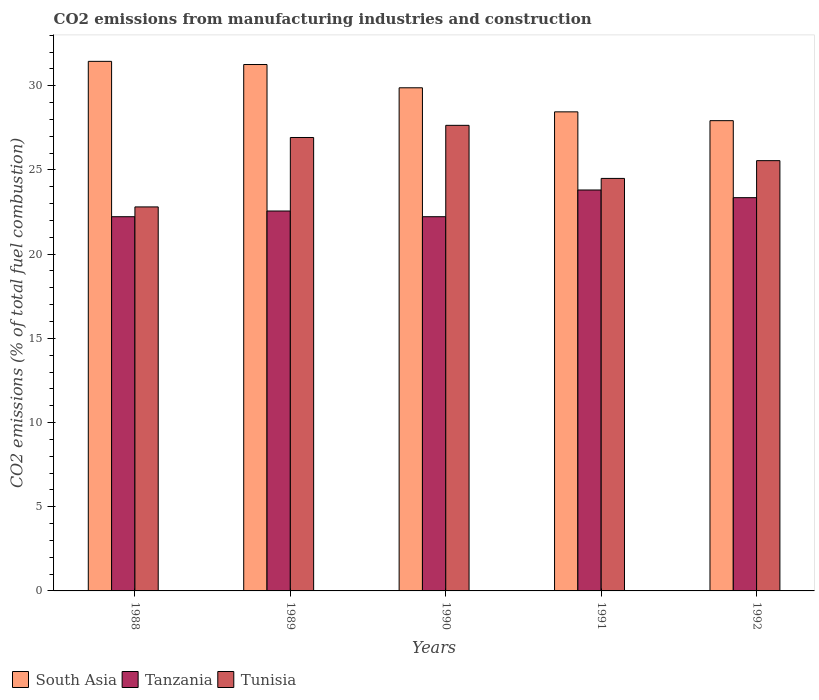How many groups of bars are there?
Your response must be concise. 5. Are the number of bars per tick equal to the number of legend labels?
Your response must be concise. Yes. Are the number of bars on each tick of the X-axis equal?
Offer a very short reply. Yes. In how many cases, is the number of bars for a given year not equal to the number of legend labels?
Provide a succinct answer. 0. What is the amount of CO2 emitted in Tunisia in 1989?
Provide a succinct answer. 26.93. Across all years, what is the maximum amount of CO2 emitted in Tunisia?
Offer a terse response. 27.65. Across all years, what is the minimum amount of CO2 emitted in South Asia?
Ensure brevity in your answer.  27.93. In which year was the amount of CO2 emitted in Tanzania minimum?
Offer a very short reply. 1988. What is the total amount of CO2 emitted in Tanzania in the graph?
Provide a succinct answer. 114.17. What is the difference between the amount of CO2 emitted in Tunisia in 1988 and that in 1992?
Your answer should be compact. -2.75. What is the difference between the amount of CO2 emitted in Tanzania in 1988 and the amount of CO2 emitted in South Asia in 1990?
Offer a terse response. -7.66. What is the average amount of CO2 emitted in South Asia per year?
Provide a succinct answer. 29.79. In the year 1992, what is the difference between the amount of CO2 emitted in South Asia and amount of CO2 emitted in Tunisia?
Keep it short and to the point. 2.37. What is the ratio of the amount of CO2 emitted in South Asia in 1991 to that in 1992?
Your answer should be compact. 1.02. Is the amount of CO2 emitted in Tunisia in 1988 less than that in 1989?
Provide a succinct answer. Yes. What is the difference between the highest and the second highest amount of CO2 emitted in Tunisia?
Give a very brief answer. 0.72. What is the difference between the highest and the lowest amount of CO2 emitted in South Asia?
Ensure brevity in your answer.  3.52. Is the sum of the amount of CO2 emitted in Tunisia in 1989 and 1990 greater than the maximum amount of CO2 emitted in Tanzania across all years?
Make the answer very short. Yes. What does the 1st bar from the left in 1992 represents?
Give a very brief answer. South Asia. What does the 2nd bar from the right in 1989 represents?
Make the answer very short. Tanzania. Is it the case that in every year, the sum of the amount of CO2 emitted in Tunisia and amount of CO2 emitted in Tanzania is greater than the amount of CO2 emitted in South Asia?
Provide a short and direct response. Yes. How many bars are there?
Provide a short and direct response. 15. Does the graph contain grids?
Ensure brevity in your answer.  No. How many legend labels are there?
Provide a succinct answer. 3. What is the title of the graph?
Ensure brevity in your answer.  CO2 emissions from manufacturing industries and construction. What is the label or title of the X-axis?
Offer a very short reply. Years. What is the label or title of the Y-axis?
Ensure brevity in your answer.  CO2 emissions (% of total fuel combustion). What is the CO2 emissions (% of total fuel combustion) in South Asia in 1988?
Ensure brevity in your answer.  31.45. What is the CO2 emissions (% of total fuel combustion) of Tanzania in 1988?
Provide a succinct answer. 22.22. What is the CO2 emissions (% of total fuel combustion) of Tunisia in 1988?
Your answer should be compact. 22.8. What is the CO2 emissions (% of total fuel combustion) in South Asia in 1989?
Your answer should be compact. 31.26. What is the CO2 emissions (% of total fuel combustion) in Tanzania in 1989?
Your answer should be very brief. 22.56. What is the CO2 emissions (% of total fuel combustion) of Tunisia in 1989?
Your response must be concise. 26.93. What is the CO2 emissions (% of total fuel combustion) in South Asia in 1990?
Offer a very short reply. 29.88. What is the CO2 emissions (% of total fuel combustion) of Tanzania in 1990?
Give a very brief answer. 22.22. What is the CO2 emissions (% of total fuel combustion) of Tunisia in 1990?
Give a very brief answer. 27.65. What is the CO2 emissions (% of total fuel combustion) in South Asia in 1991?
Keep it short and to the point. 28.45. What is the CO2 emissions (% of total fuel combustion) of Tanzania in 1991?
Provide a short and direct response. 23.81. What is the CO2 emissions (% of total fuel combustion) in Tunisia in 1991?
Ensure brevity in your answer.  24.5. What is the CO2 emissions (% of total fuel combustion) of South Asia in 1992?
Provide a short and direct response. 27.93. What is the CO2 emissions (% of total fuel combustion) of Tanzania in 1992?
Your answer should be very brief. 23.35. What is the CO2 emissions (% of total fuel combustion) of Tunisia in 1992?
Your answer should be very brief. 25.55. Across all years, what is the maximum CO2 emissions (% of total fuel combustion) in South Asia?
Your response must be concise. 31.45. Across all years, what is the maximum CO2 emissions (% of total fuel combustion) of Tanzania?
Offer a very short reply. 23.81. Across all years, what is the maximum CO2 emissions (% of total fuel combustion) of Tunisia?
Offer a terse response. 27.65. Across all years, what is the minimum CO2 emissions (% of total fuel combustion) of South Asia?
Your answer should be compact. 27.93. Across all years, what is the minimum CO2 emissions (% of total fuel combustion) in Tanzania?
Provide a succinct answer. 22.22. Across all years, what is the minimum CO2 emissions (% of total fuel combustion) of Tunisia?
Your answer should be very brief. 22.8. What is the total CO2 emissions (% of total fuel combustion) in South Asia in the graph?
Give a very brief answer. 148.96. What is the total CO2 emissions (% of total fuel combustion) in Tanzania in the graph?
Offer a very short reply. 114.17. What is the total CO2 emissions (% of total fuel combustion) of Tunisia in the graph?
Offer a terse response. 127.43. What is the difference between the CO2 emissions (% of total fuel combustion) of South Asia in 1988 and that in 1989?
Your answer should be very brief. 0.19. What is the difference between the CO2 emissions (% of total fuel combustion) in Tanzania in 1988 and that in 1989?
Offer a terse response. -0.34. What is the difference between the CO2 emissions (% of total fuel combustion) in Tunisia in 1988 and that in 1989?
Provide a short and direct response. -4.12. What is the difference between the CO2 emissions (% of total fuel combustion) in South Asia in 1988 and that in 1990?
Your answer should be compact. 1.57. What is the difference between the CO2 emissions (% of total fuel combustion) of Tunisia in 1988 and that in 1990?
Provide a short and direct response. -4.85. What is the difference between the CO2 emissions (% of total fuel combustion) in South Asia in 1988 and that in 1991?
Keep it short and to the point. 3. What is the difference between the CO2 emissions (% of total fuel combustion) in Tanzania in 1988 and that in 1991?
Provide a succinct answer. -1.59. What is the difference between the CO2 emissions (% of total fuel combustion) in Tunisia in 1988 and that in 1991?
Offer a terse response. -1.69. What is the difference between the CO2 emissions (% of total fuel combustion) in South Asia in 1988 and that in 1992?
Ensure brevity in your answer.  3.52. What is the difference between the CO2 emissions (% of total fuel combustion) in Tanzania in 1988 and that in 1992?
Offer a terse response. -1.13. What is the difference between the CO2 emissions (% of total fuel combustion) of Tunisia in 1988 and that in 1992?
Provide a short and direct response. -2.75. What is the difference between the CO2 emissions (% of total fuel combustion) in South Asia in 1989 and that in 1990?
Provide a succinct answer. 1.38. What is the difference between the CO2 emissions (% of total fuel combustion) of Tanzania in 1989 and that in 1990?
Make the answer very short. 0.34. What is the difference between the CO2 emissions (% of total fuel combustion) in Tunisia in 1989 and that in 1990?
Ensure brevity in your answer.  -0.72. What is the difference between the CO2 emissions (% of total fuel combustion) of South Asia in 1989 and that in 1991?
Ensure brevity in your answer.  2.81. What is the difference between the CO2 emissions (% of total fuel combustion) in Tanzania in 1989 and that in 1991?
Your answer should be compact. -1.25. What is the difference between the CO2 emissions (% of total fuel combustion) of Tunisia in 1989 and that in 1991?
Your response must be concise. 2.43. What is the difference between the CO2 emissions (% of total fuel combustion) of South Asia in 1989 and that in 1992?
Give a very brief answer. 3.33. What is the difference between the CO2 emissions (% of total fuel combustion) in Tanzania in 1989 and that in 1992?
Your answer should be very brief. -0.79. What is the difference between the CO2 emissions (% of total fuel combustion) of Tunisia in 1989 and that in 1992?
Your answer should be very brief. 1.38. What is the difference between the CO2 emissions (% of total fuel combustion) of South Asia in 1990 and that in 1991?
Your answer should be compact. 1.43. What is the difference between the CO2 emissions (% of total fuel combustion) in Tanzania in 1990 and that in 1991?
Offer a terse response. -1.59. What is the difference between the CO2 emissions (% of total fuel combustion) of Tunisia in 1990 and that in 1991?
Keep it short and to the point. 3.15. What is the difference between the CO2 emissions (% of total fuel combustion) of South Asia in 1990 and that in 1992?
Offer a very short reply. 1.95. What is the difference between the CO2 emissions (% of total fuel combustion) in Tanzania in 1990 and that in 1992?
Keep it short and to the point. -1.13. What is the difference between the CO2 emissions (% of total fuel combustion) in Tunisia in 1990 and that in 1992?
Your answer should be compact. 2.1. What is the difference between the CO2 emissions (% of total fuel combustion) of South Asia in 1991 and that in 1992?
Your answer should be compact. 0.52. What is the difference between the CO2 emissions (% of total fuel combustion) of Tanzania in 1991 and that in 1992?
Give a very brief answer. 0.46. What is the difference between the CO2 emissions (% of total fuel combustion) of Tunisia in 1991 and that in 1992?
Provide a succinct answer. -1.05. What is the difference between the CO2 emissions (% of total fuel combustion) in South Asia in 1988 and the CO2 emissions (% of total fuel combustion) in Tanzania in 1989?
Ensure brevity in your answer.  8.89. What is the difference between the CO2 emissions (% of total fuel combustion) of South Asia in 1988 and the CO2 emissions (% of total fuel combustion) of Tunisia in 1989?
Ensure brevity in your answer.  4.52. What is the difference between the CO2 emissions (% of total fuel combustion) in Tanzania in 1988 and the CO2 emissions (% of total fuel combustion) in Tunisia in 1989?
Provide a short and direct response. -4.7. What is the difference between the CO2 emissions (% of total fuel combustion) of South Asia in 1988 and the CO2 emissions (% of total fuel combustion) of Tanzania in 1990?
Provide a short and direct response. 9.23. What is the difference between the CO2 emissions (% of total fuel combustion) in South Asia in 1988 and the CO2 emissions (% of total fuel combustion) in Tunisia in 1990?
Ensure brevity in your answer.  3.8. What is the difference between the CO2 emissions (% of total fuel combustion) of Tanzania in 1988 and the CO2 emissions (% of total fuel combustion) of Tunisia in 1990?
Offer a terse response. -5.43. What is the difference between the CO2 emissions (% of total fuel combustion) of South Asia in 1988 and the CO2 emissions (% of total fuel combustion) of Tanzania in 1991?
Provide a succinct answer. 7.64. What is the difference between the CO2 emissions (% of total fuel combustion) of South Asia in 1988 and the CO2 emissions (% of total fuel combustion) of Tunisia in 1991?
Your answer should be compact. 6.95. What is the difference between the CO2 emissions (% of total fuel combustion) of Tanzania in 1988 and the CO2 emissions (% of total fuel combustion) of Tunisia in 1991?
Provide a short and direct response. -2.27. What is the difference between the CO2 emissions (% of total fuel combustion) in South Asia in 1988 and the CO2 emissions (% of total fuel combustion) in Tanzania in 1992?
Offer a very short reply. 8.09. What is the difference between the CO2 emissions (% of total fuel combustion) of South Asia in 1988 and the CO2 emissions (% of total fuel combustion) of Tunisia in 1992?
Provide a short and direct response. 5.9. What is the difference between the CO2 emissions (% of total fuel combustion) of Tanzania in 1988 and the CO2 emissions (% of total fuel combustion) of Tunisia in 1992?
Ensure brevity in your answer.  -3.33. What is the difference between the CO2 emissions (% of total fuel combustion) of South Asia in 1989 and the CO2 emissions (% of total fuel combustion) of Tanzania in 1990?
Your answer should be very brief. 9.04. What is the difference between the CO2 emissions (% of total fuel combustion) of South Asia in 1989 and the CO2 emissions (% of total fuel combustion) of Tunisia in 1990?
Give a very brief answer. 3.61. What is the difference between the CO2 emissions (% of total fuel combustion) of Tanzania in 1989 and the CO2 emissions (% of total fuel combustion) of Tunisia in 1990?
Provide a succinct answer. -5.09. What is the difference between the CO2 emissions (% of total fuel combustion) in South Asia in 1989 and the CO2 emissions (% of total fuel combustion) in Tanzania in 1991?
Provide a succinct answer. 7.45. What is the difference between the CO2 emissions (% of total fuel combustion) in South Asia in 1989 and the CO2 emissions (% of total fuel combustion) in Tunisia in 1991?
Offer a very short reply. 6.76. What is the difference between the CO2 emissions (% of total fuel combustion) in Tanzania in 1989 and the CO2 emissions (% of total fuel combustion) in Tunisia in 1991?
Your response must be concise. -1.94. What is the difference between the CO2 emissions (% of total fuel combustion) in South Asia in 1989 and the CO2 emissions (% of total fuel combustion) in Tanzania in 1992?
Offer a very short reply. 7.91. What is the difference between the CO2 emissions (% of total fuel combustion) of South Asia in 1989 and the CO2 emissions (% of total fuel combustion) of Tunisia in 1992?
Your answer should be compact. 5.71. What is the difference between the CO2 emissions (% of total fuel combustion) of Tanzania in 1989 and the CO2 emissions (% of total fuel combustion) of Tunisia in 1992?
Your answer should be compact. -2.99. What is the difference between the CO2 emissions (% of total fuel combustion) of South Asia in 1990 and the CO2 emissions (% of total fuel combustion) of Tanzania in 1991?
Your response must be concise. 6.07. What is the difference between the CO2 emissions (% of total fuel combustion) in South Asia in 1990 and the CO2 emissions (% of total fuel combustion) in Tunisia in 1991?
Offer a very short reply. 5.38. What is the difference between the CO2 emissions (% of total fuel combustion) of Tanzania in 1990 and the CO2 emissions (% of total fuel combustion) of Tunisia in 1991?
Keep it short and to the point. -2.27. What is the difference between the CO2 emissions (% of total fuel combustion) in South Asia in 1990 and the CO2 emissions (% of total fuel combustion) in Tanzania in 1992?
Offer a very short reply. 6.53. What is the difference between the CO2 emissions (% of total fuel combustion) of South Asia in 1990 and the CO2 emissions (% of total fuel combustion) of Tunisia in 1992?
Your response must be concise. 4.33. What is the difference between the CO2 emissions (% of total fuel combustion) in Tanzania in 1990 and the CO2 emissions (% of total fuel combustion) in Tunisia in 1992?
Provide a succinct answer. -3.33. What is the difference between the CO2 emissions (% of total fuel combustion) in South Asia in 1991 and the CO2 emissions (% of total fuel combustion) in Tanzania in 1992?
Keep it short and to the point. 5.1. What is the difference between the CO2 emissions (% of total fuel combustion) in South Asia in 1991 and the CO2 emissions (% of total fuel combustion) in Tunisia in 1992?
Your response must be concise. 2.9. What is the difference between the CO2 emissions (% of total fuel combustion) of Tanzania in 1991 and the CO2 emissions (% of total fuel combustion) of Tunisia in 1992?
Offer a terse response. -1.74. What is the average CO2 emissions (% of total fuel combustion) in South Asia per year?
Offer a very short reply. 29.79. What is the average CO2 emissions (% of total fuel combustion) in Tanzania per year?
Ensure brevity in your answer.  22.83. What is the average CO2 emissions (% of total fuel combustion) in Tunisia per year?
Ensure brevity in your answer.  25.49. In the year 1988, what is the difference between the CO2 emissions (% of total fuel combustion) of South Asia and CO2 emissions (% of total fuel combustion) of Tanzania?
Provide a short and direct response. 9.23. In the year 1988, what is the difference between the CO2 emissions (% of total fuel combustion) of South Asia and CO2 emissions (% of total fuel combustion) of Tunisia?
Your answer should be compact. 8.64. In the year 1988, what is the difference between the CO2 emissions (% of total fuel combustion) in Tanzania and CO2 emissions (% of total fuel combustion) in Tunisia?
Offer a terse response. -0.58. In the year 1989, what is the difference between the CO2 emissions (% of total fuel combustion) of South Asia and CO2 emissions (% of total fuel combustion) of Tanzania?
Make the answer very short. 8.7. In the year 1989, what is the difference between the CO2 emissions (% of total fuel combustion) of South Asia and CO2 emissions (% of total fuel combustion) of Tunisia?
Offer a very short reply. 4.33. In the year 1989, what is the difference between the CO2 emissions (% of total fuel combustion) in Tanzania and CO2 emissions (% of total fuel combustion) in Tunisia?
Make the answer very short. -4.37. In the year 1990, what is the difference between the CO2 emissions (% of total fuel combustion) of South Asia and CO2 emissions (% of total fuel combustion) of Tanzania?
Provide a short and direct response. 7.66. In the year 1990, what is the difference between the CO2 emissions (% of total fuel combustion) in South Asia and CO2 emissions (% of total fuel combustion) in Tunisia?
Your answer should be very brief. 2.23. In the year 1990, what is the difference between the CO2 emissions (% of total fuel combustion) of Tanzania and CO2 emissions (% of total fuel combustion) of Tunisia?
Your response must be concise. -5.43. In the year 1991, what is the difference between the CO2 emissions (% of total fuel combustion) in South Asia and CO2 emissions (% of total fuel combustion) in Tanzania?
Provide a short and direct response. 4.64. In the year 1991, what is the difference between the CO2 emissions (% of total fuel combustion) in South Asia and CO2 emissions (% of total fuel combustion) in Tunisia?
Provide a succinct answer. 3.95. In the year 1991, what is the difference between the CO2 emissions (% of total fuel combustion) of Tanzania and CO2 emissions (% of total fuel combustion) of Tunisia?
Your response must be concise. -0.69. In the year 1992, what is the difference between the CO2 emissions (% of total fuel combustion) in South Asia and CO2 emissions (% of total fuel combustion) in Tanzania?
Give a very brief answer. 4.57. In the year 1992, what is the difference between the CO2 emissions (% of total fuel combustion) in South Asia and CO2 emissions (% of total fuel combustion) in Tunisia?
Your response must be concise. 2.37. In the year 1992, what is the difference between the CO2 emissions (% of total fuel combustion) of Tanzania and CO2 emissions (% of total fuel combustion) of Tunisia?
Keep it short and to the point. -2.2. What is the ratio of the CO2 emissions (% of total fuel combustion) in South Asia in 1988 to that in 1989?
Provide a succinct answer. 1.01. What is the ratio of the CO2 emissions (% of total fuel combustion) in Tanzania in 1988 to that in 1989?
Provide a succinct answer. 0.98. What is the ratio of the CO2 emissions (% of total fuel combustion) in Tunisia in 1988 to that in 1989?
Provide a succinct answer. 0.85. What is the ratio of the CO2 emissions (% of total fuel combustion) in South Asia in 1988 to that in 1990?
Your answer should be compact. 1.05. What is the ratio of the CO2 emissions (% of total fuel combustion) in Tunisia in 1988 to that in 1990?
Make the answer very short. 0.82. What is the ratio of the CO2 emissions (% of total fuel combustion) in South Asia in 1988 to that in 1991?
Your answer should be very brief. 1.11. What is the ratio of the CO2 emissions (% of total fuel combustion) of Tunisia in 1988 to that in 1991?
Keep it short and to the point. 0.93. What is the ratio of the CO2 emissions (% of total fuel combustion) in South Asia in 1988 to that in 1992?
Your response must be concise. 1.13. What is the ratio of the CO2 emissions (% of total fuel combustion) of Tanzania in 1988 to that in 1992?
Your answer should be compact. 0.95. What is the ratio of the CO2 emissions (% of total fuel combustion) of Tunisia in 1988 to that in 1992?
Ensure brevity in your answer.  0.89. What is the ratio of the CO2 emissions (% of total fuel combustion) of South Asia in 1989 to that in 1990?
Keep it short and to the point. 1.05. What is the ratio of the CO2 emissions (% of total fuel combustion) in Tanzania in 1989 to that in 1990?
Your answer should be compact. 1.02. What is the ratio of the CO2 emissions (% of total fuel combustion) in Tunisia in 1989 to that in 1990?
Your answer should be very brief. 0.97. What is the ratio of the CO2 emissions (% of total fuel combustion) of South Asia in 1989 to that in 1991?
Your answer should be compact. 1.1. What is the ratio of the CO2 emissions (% of total fuel combustion) of Tanzania in 1989 to that in 1991?
Offer a very short reply. 0.95. What is the ratio of the CO2 emissions (% of total fuel combustion) of Tunisia in 1989 to that in 1991?
Provide a short and direct response. 1.1. What is the ratio of the CO2 emissions (% of total fuel combustion) in South Asia in 1989 to that in 1992?
Make the answer very short. 1.12. What is the ratio of the CO2 emissions (% of total fuel combustion) of Tanzania in 1989 to that in 1992?
Your answer should be compact. 0.97. What is the ratio of the CO2 emissions (% of total fuel combustion) of Tunisia in 1989 to that in 1992?
Provide a short and direct response. 1.05. What is the ratio of the CO2 emissions (% of total fuel combustion) in South Asia in 1990 to that in 1991?
Offer a very short reply. 1.05. What is the ratio of the CO2 emissions (% of total fuel combustion) of Tunisia in 1990 to that in 1991?
Your answer should be compact. 1.13. What is the ratio of the CO2 emissions (% of total fuel combustion) in South Asia in 1990 to that in 1992?
Keep it short and to the point. 1.07. What is the ratio of the CO2 emissions (% of total fuel combustion) of Tanzania in 1990 to that in 1992?
Offer a very short reply. 0.95. What is the ratio of the CO2 emissions (% of total fuel combustion) in Tunisia in 1990 to that in 1992?
Provide a succinct answer. 1.08. What is the ratio of the CO2 emissions (% of total fuel combustion) of South Asia in 1991 to that in 1992?
Keep it short and to the point. 1.02. What is the ratio of the CO2 emissions (% of total fuel combustion) in Tanzania in 1991 to that in 1992?
Your answer should be very brief. 1.02. What is the ratio of the CO2 emissions (% of total fuel combustion) of Tunisia in 1991 to that in 1992?
Offer a terse response. 0.96. What is the difference between the highest and the second highest CO2 emissions (% of total fuel combustion) in South Asia?
Ensure brevity in your answer.  0.19. What is the difference between the highest and the second highest CO2 emissions (% of total fuel combustion) in Tanzania?
Keep it short and to the point. 0.46. What is the difference between the highest and the second highest CO2 emissions (% of total fuel combustion) in Tunisia?
Make the answer very short. 0.72. What is the difference between the highest and the lowest CO2 emissions (% of total fuel combustion) of South Asia?
Offer a terse response. 3.52. What is the difference between the highest and the lowest CO2 emissions (% of total fuel combustion) of Tanzania?
Your answer should be very brief. 1.59. What is the difference between the highest and the lowest CO2 emissions (% of total fuel combustion) in Tunisia?
Your answer should be very brief. 4.85. 